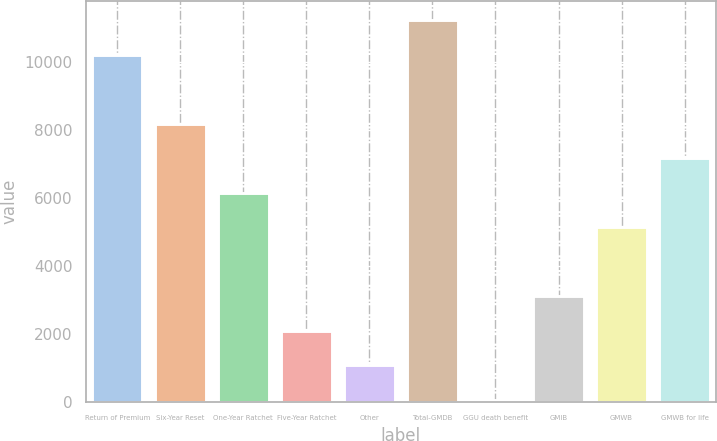<chart> <loc_0><loc_0><loc_500><loc_500><bar_chart><fcel>Return of Premium<fcel>Six-Year Reset<fcel>One-Year Ratchet<fcel>Five-Year Ratchet<fcel>Other<fcel>Total-GMDB<fcel>GGU death benefit<fcel>GMIB<fcel>GMWB<fcel>GMWB for life<nl><fcel>10229<fcel>8196.2<fcel>6163.4<fcel>2097.8<fcel>1081.4<fcel>11245.4<fcel>65<fcel>3114.2<fcel>5147<fcel>7179.8<nl></chart> 